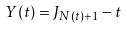<formula> <loc_0><loc_0><loc_500><loc_500>Y ( t ) = J _ { N ( t ) + 1 } - t</formula> 